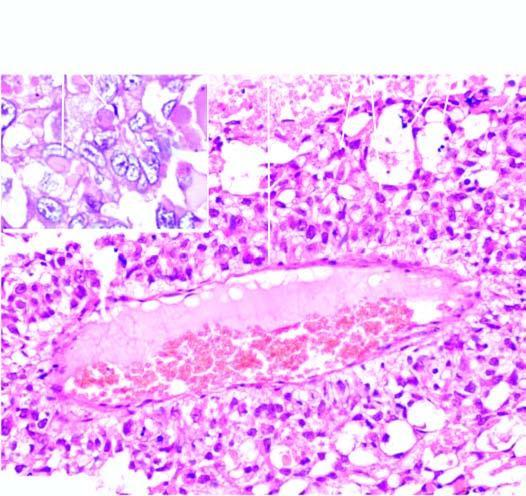what are present?
Answer the question using a single word or phrase. Several characteristic schiller-duval bodies 